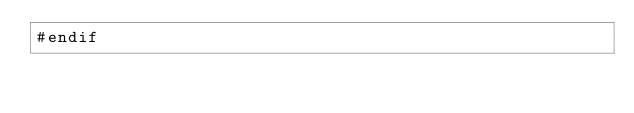Convert code to text. <code><loc_0><loc_0><loc_500><loc_500><_Cuda_>#endif
</code> 